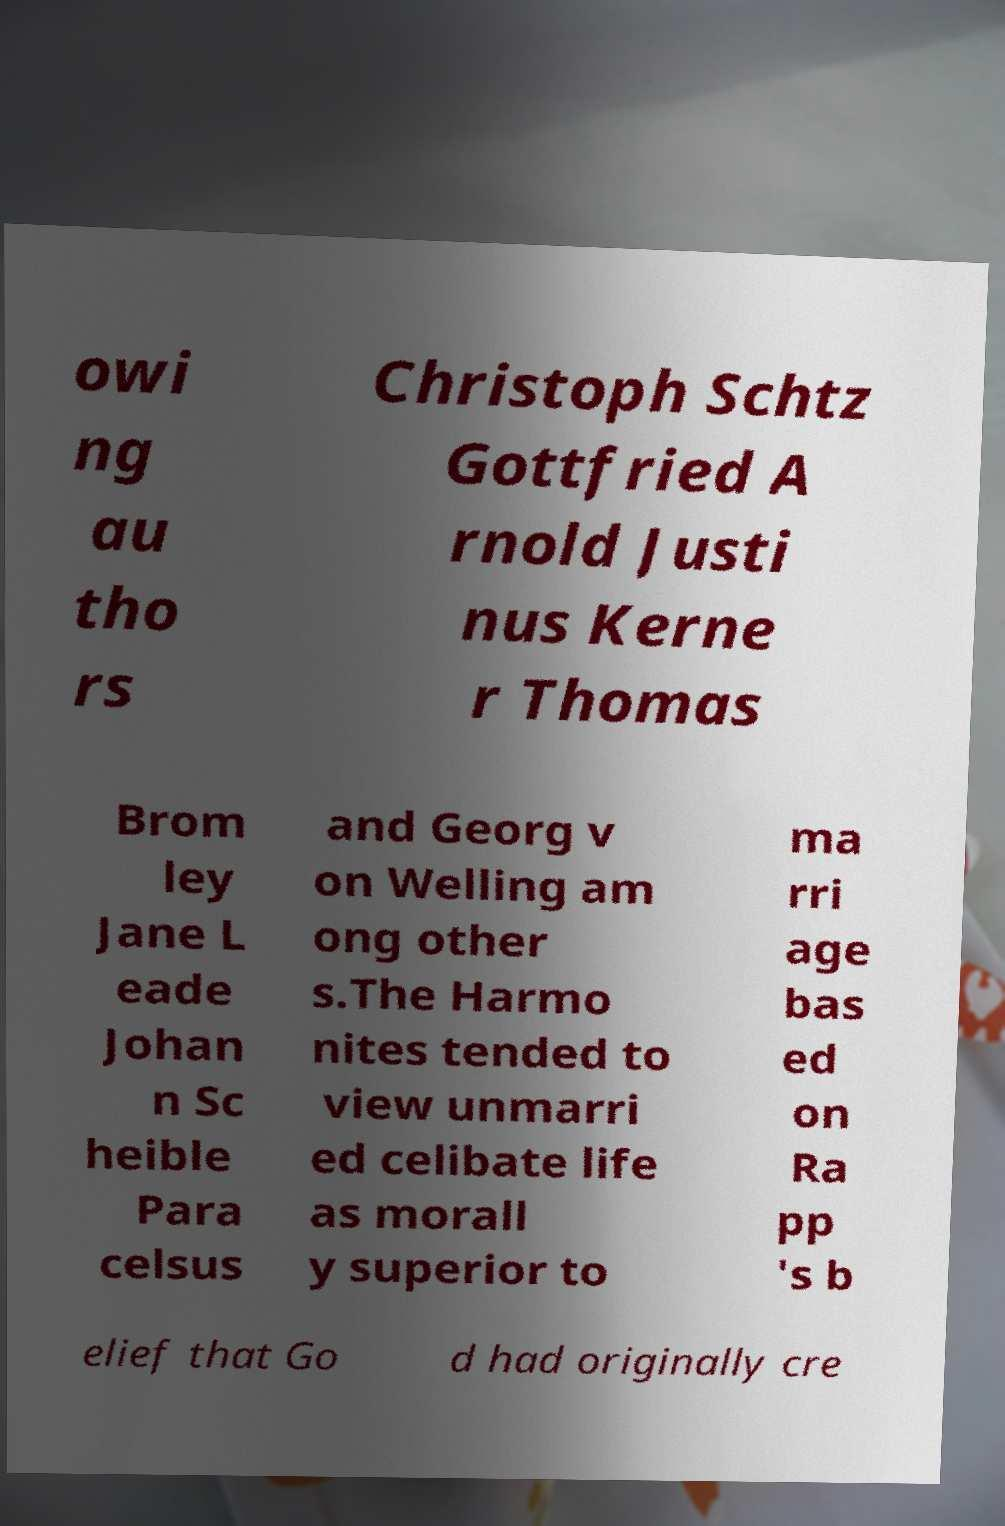For documentation purposes, I need the text within this image transcribed. Could you provide that? owi ng au tho rs Christoph Schtz Gottfried A rnold Justi nus Kerne r Thomas Brom ley Jane L eade Johan n Sc heible Para celsus and Georg v on Welling am ong other s.The Harmo nites tended to view unmarri ed celibate life as morall y superior to ma rri age bas ed on Ra pp 's b elief that Go d had originally cre 